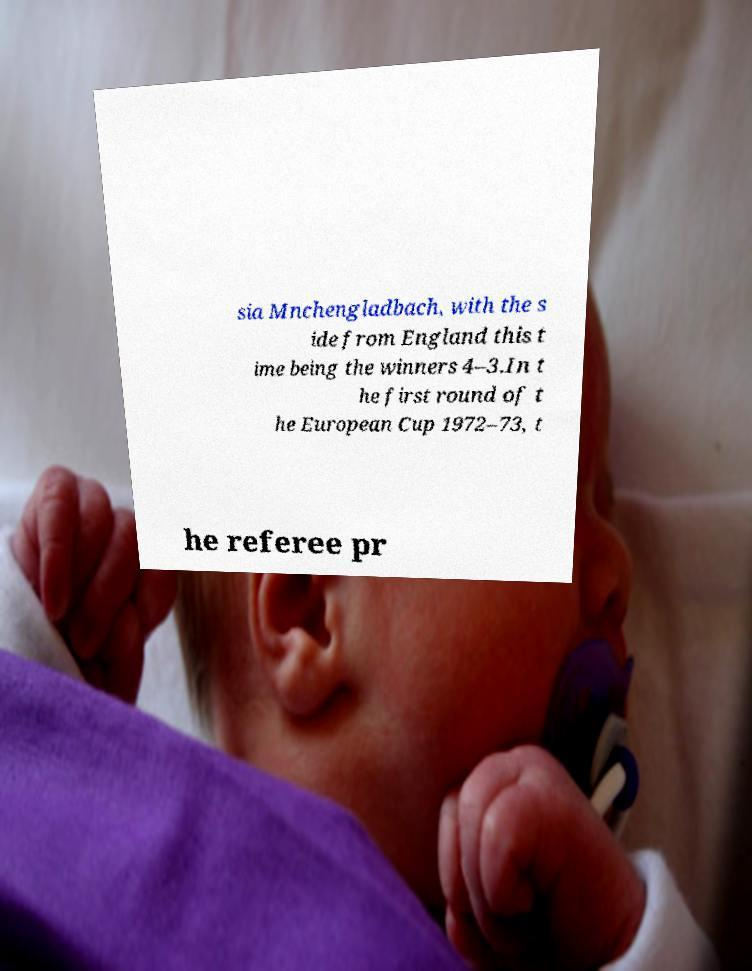I need the written content from this picture converted into text. Can you do that? sia Mnchengladbach, with the s ide from England this t ime being the winners 4–3.In t he first round of t he European Cup 1972–73, t he referee pr 